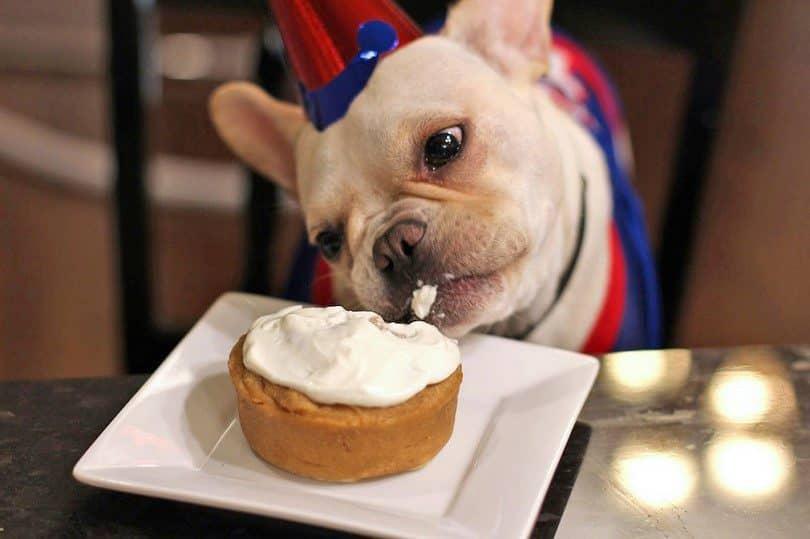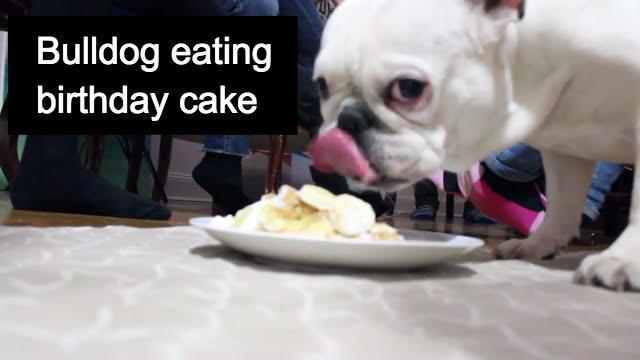The first image is the image on the left, the second image is the image on the right. Examine the images to the left and right. Is the description "There is a serving of fresh fruit in front of a black puppy." accurate? Answer yes or no. No. The first image is the image on the left, the second image is the image on the right. Examine the images to the left and right. Is the description "The head of a dark big-eared dog is behind a container of fresh red fruit." accurate? Answer yes or no. No. 